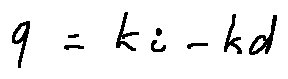<formula> <loc_0><loc_0><loc_500><loc_500>q = k _ { i } - k _ { d }</formula> 